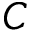<formula> <loc_0><loc_0><loc_500><loc_500>C</formula> 